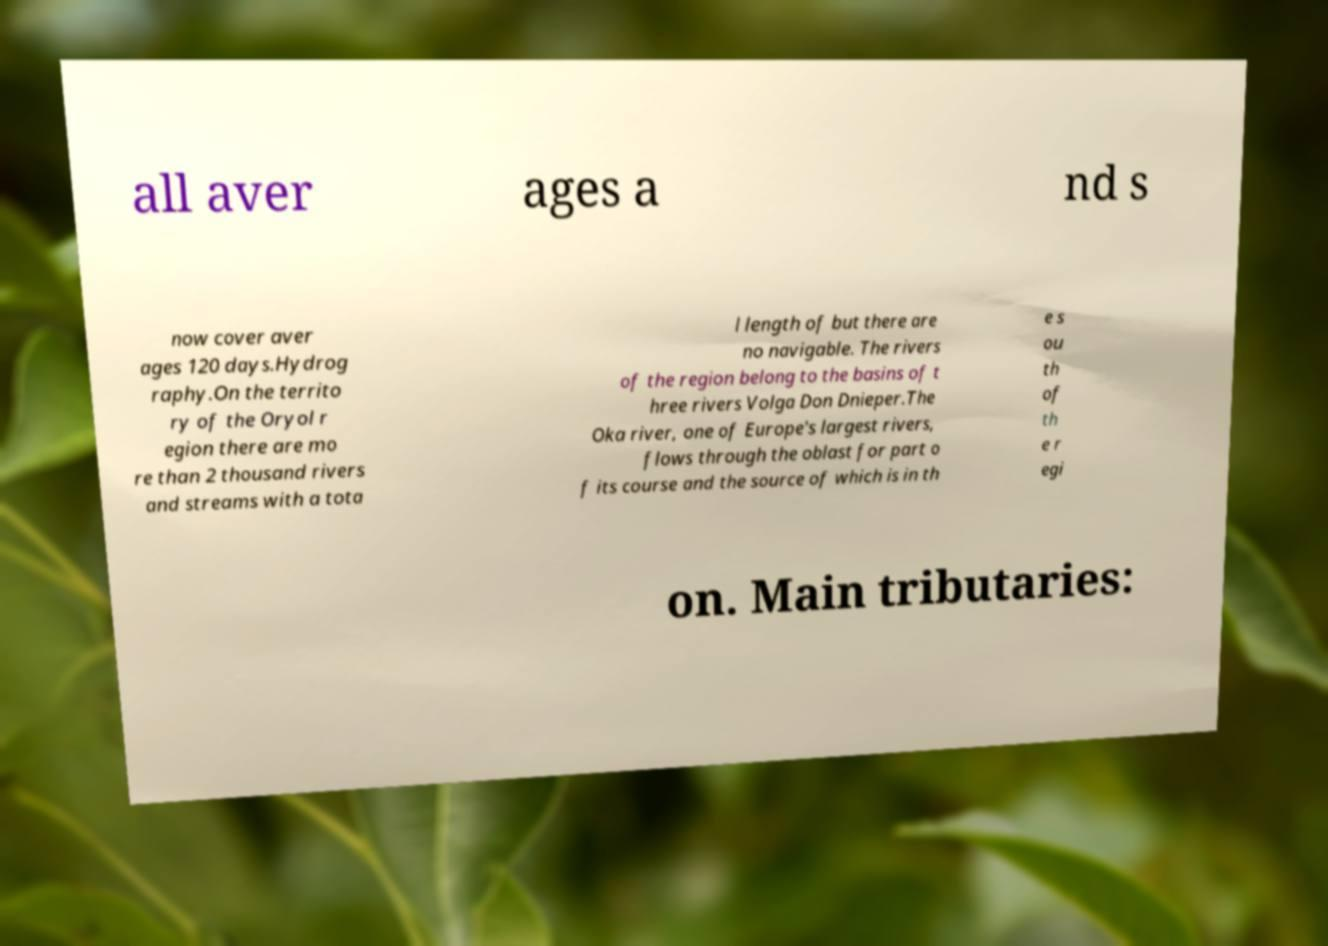For documentation purposes, I need the text within this image transcribed. Could you provide that? all aver ages a nd s now cover aver ages 120 days.Hydrog raphy.On the territo ry of the Oryol r egion there are mo re than 2 thousand rivers and streams with a tota l length of but there are no navigable. The rivers of the region belong to the basins of t hree rivers Volga Don Dnieper.The Oka river, one of Europe's largest rivers, flows through the oblast for part o f its course and the source of which is in th e s ou th of th e r egi on. Main tributaries: 